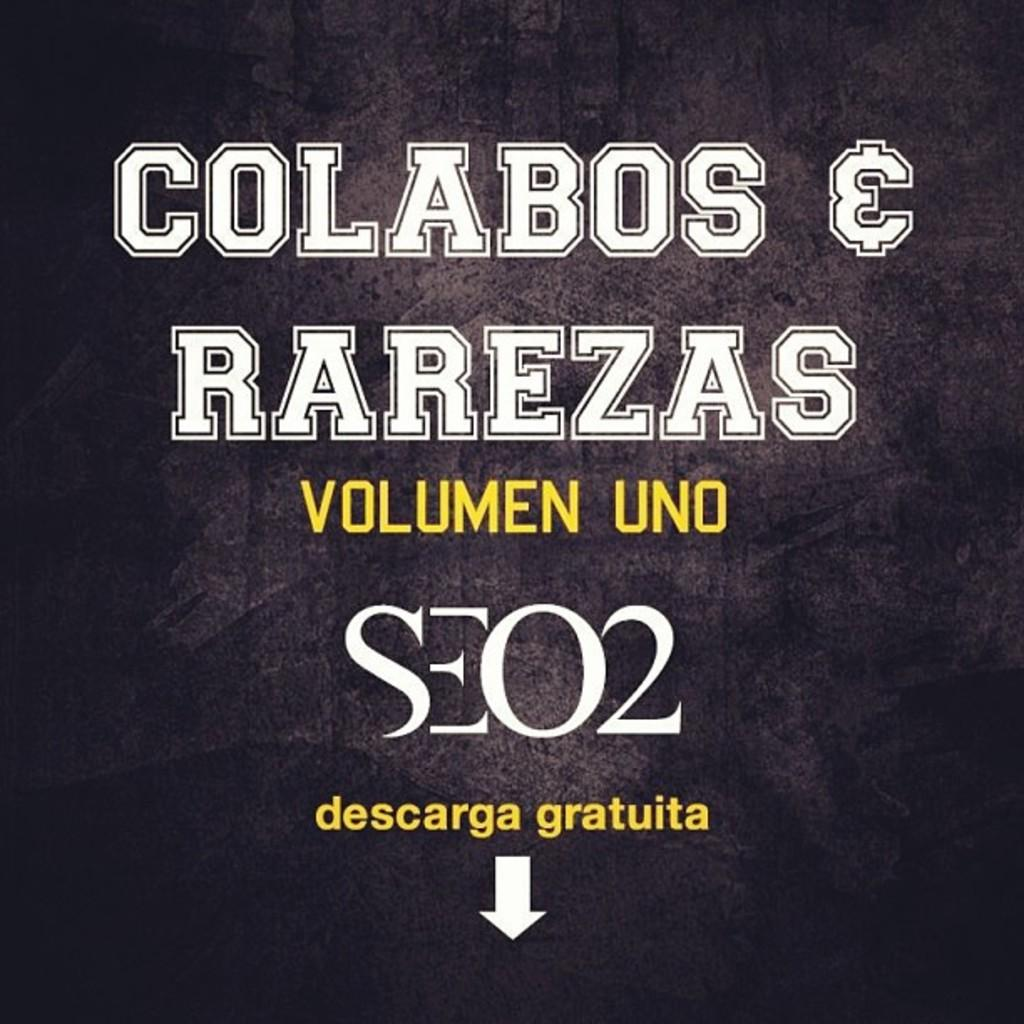<image>
Present a compact description of the photo's key features. A cover of an album which states volume one with an arrow pointing down for a free download. 